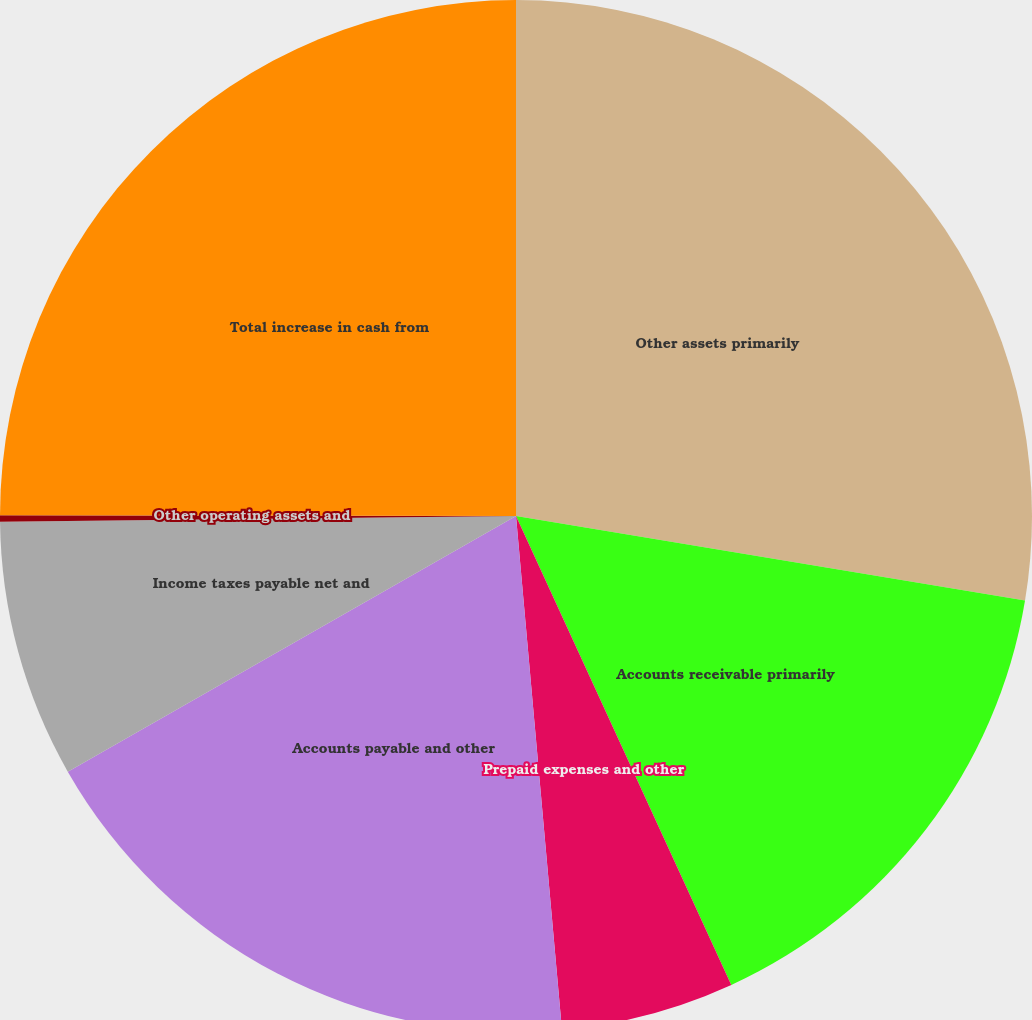<chart> <loc_0><loc_0><loc_500><loc_500><pie_chart><fcel>Other assets primarily<fcel>Accounts receivable primarily<fcel>Prepaid expenses and other<fcel>Accounts payable and other<fcel>Income taxes payable net and<fcel>Other operating assets and<fcel>Total increase in cash from<nl><fcel>27.62%<fcel>15.53%<fcel>5.43%<fcel>18.17%<fcel>8.07%<fcel>0.2%<fcel>24.98%<nl></chart> 